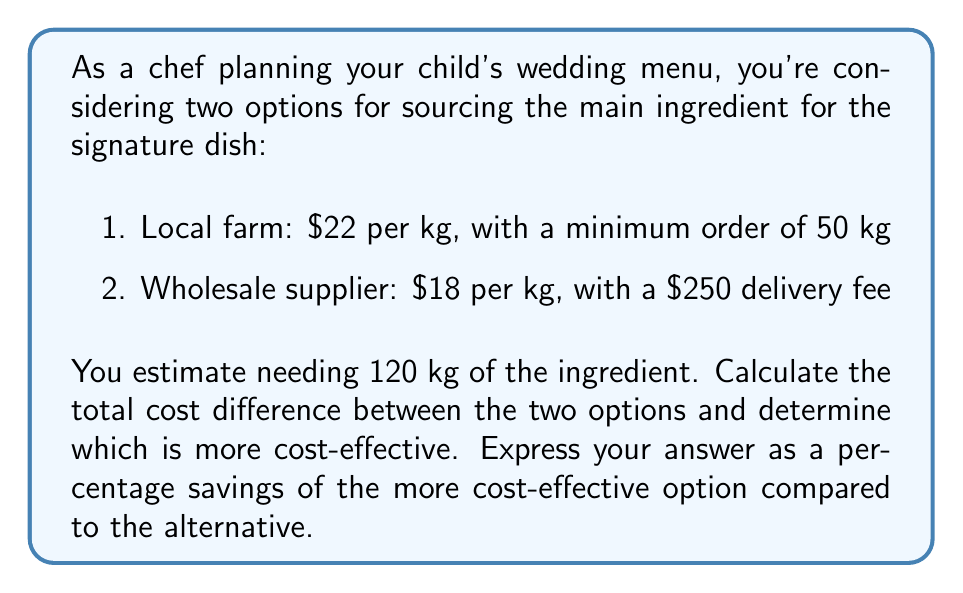Could you help me with this problem? Let's approach this problem step-by-step:

1. Calculate the cost for the local farm option:
   * Minimum order is 50 kg, but we need 120 kg
   * Cost = $22 per kg × 120 kg
   * Total cost for local farm = $22 × 120 = $2,640

2. Calculate the cost for the wholesale supplier option:
   * Cost = (Price per kg × Quantity) + Delivery fee
   * Total cost for wholesale = ($18 × 120) + $250
   * Total cost for wholesale = $2,160 + $250 = $2,410

3. Calculate the difference in cost:
   * Difference = Local farm cost - Wholesale cost
   * Difference = $2,640 - $2,410 = $230

4. Determine which option is more cost-effective:
   The wholesale supplier is more cost-effective as it results in a lower total cost.

5. Calculate the percentage savings:
   * Percentage savings = (Cost difference / Higher cost) × 100
   * Percentage savings = ($230 / $2,640) × 100
   * Percentage savings ≈ 8.71%

Therefore, choosing the wholesale supplier would result in approximately 8.71% savings compared to the local farm option.
Answer: The wholesale supplier is more cost-effective, resulting in 8.71% savings compared to the local farm option. 